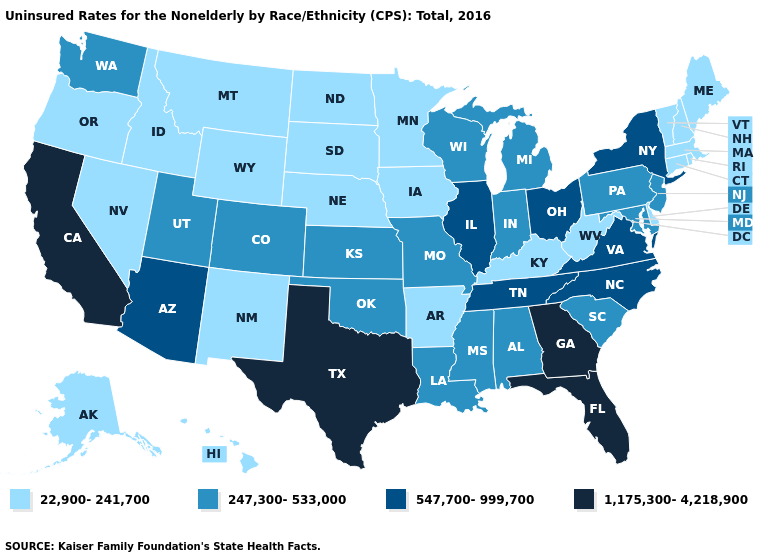What is the highest value in the MidWest ?
Be succinct. 547,700-999,700. Among the states that border Vermont , does New York have the highest value?
Keep it brief. Yes. Name the states that have a value in the range 547,700-999,700?
Concise answer only. Arizona, Illinois, New York, North Carolina, Ohio, Tennessee, Virginia. Does Nebraska have the highest value in the USA?
Write a very short answer. No. What is the lowest value in the West?
Answer briefly. 22,900-241,700. Does Tennessee have a lower value than Iowa?
Concise answer only. No. What is the lowest value in states that border South Dakota?
Short answer required. 22,900-241,700. Does Tennessee have a lower value than Oregon?
Be succinct. No. Does Minnesota have the same value as South Dakota?
Quick response, please. Yes. What is the value of Delaware?
Short answer required. 22,900-241,700. Name the states that have a value in the range 22,900-241,700?
Write a very short answer. Alaska, Arkansas, Connecticut, Delaware, Hawaii, Idaho, Iowa, Kentucky, Maine, Massachusetts, Minnesota, Montana, Nebraska, Nevada, New Hampshire, New Mexico, North Dakota, Oregon, Rhode Island, South Dakota, Vermont, West Virginia, Wyoming. What is the value of Louisiana?
Concise answer only. 247,300-533,000. What is the lowest value in states that border Illinois?
Give a very brief answer. 22,900-241,700. 